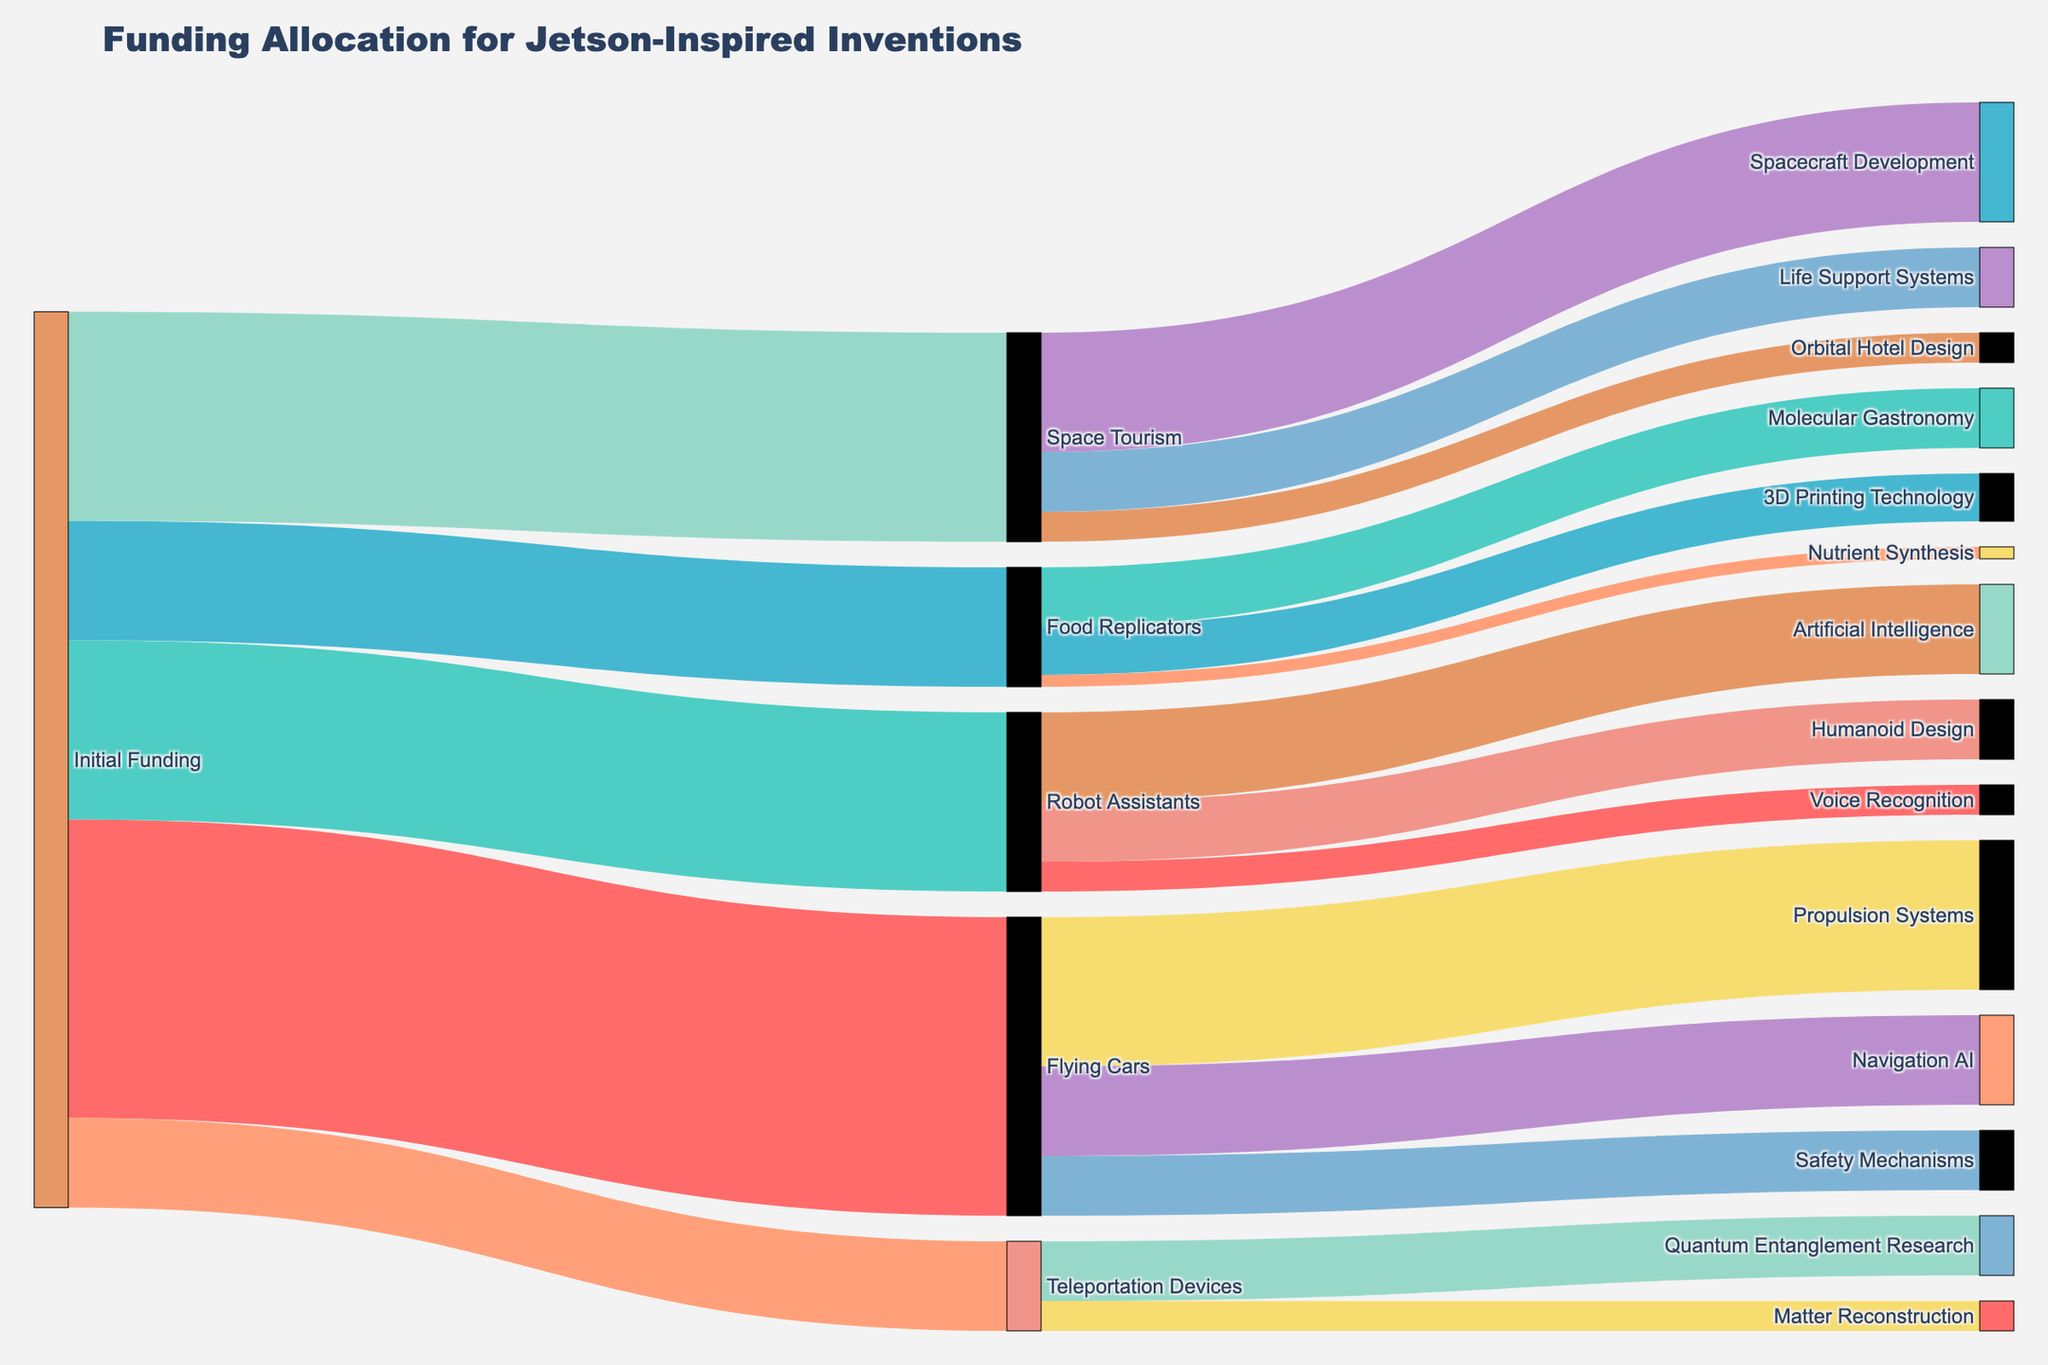What is the primary title of the figure? The title of the figure is displayed at the top, and it reads "Funding Allocation for Jetson-Inspired Inventions".
Answer: Funding Allocation for Jetson-Inspired Inventions How much initial funding was allocated to 'Robot Assistants'? The diagram shows an initial funding allocation line leading to 'Robot Assistants' with a value of 3,000,000.
Answer: 3,000,000 Which sub-category receives the most funding under 'Flying Cars'? There are three sub-categories under 'Flying Cars': Propulsion Systems, Navigation AI, and Safety Mechanisms. Propulsion Systems has the highest value at 2,500,000.
Answer: Propulsion Systems What is the total amount of initial funding allocated to all categories? The figure shows four initial funding allocations: Flying Cars (5,000,000), Robot Assistants (3,000,000), Food Replicators (2,000,000), Teleportation Devices (1,500,000), and Space Tourism (3,500,000). Adding these together: 5,000,000 + 3,000,000 + 2,000,000 + 1,500,000 + 3,500,000 = 15,000,000.
Answer: 15,000,000 Which category receives the least initial funding allocation? Observing the initial funding allocation values, 'Teleportation Devices' receives the least with a value of 1,500,000.
Answer: Teleportation Devices Compare the funding allocated to 'Artificial Intelligence' under 'Robot Assistants' versus 'Navigation AI' under 'Flying Cars'. Which receives more? The values show 'Artificial Intelligence' at 1,500,000 and 'Navigation AI' at 1,500,000. Both receive the same amount of funding.
Answer: Both the same How does the funding for 'Quantum Entanglement Research' compare to '3D Printing Technology'? The figure shows 'Quantum Entanglement Research' under 'Teleportation Devices' with 1,000,000 and '3D Printing Technology' under 'Food Replicators' with 800,000. Quantum Entanglement Research has more funding at 1,000,000.
Answer: Quantum Entanglement Research What is the total funding allocated to sub-categories under 'Space Tourism'? The sub-category values under 'Space Tourism' are: Spacecraft Development (2,000,000), Life Support Systems (1,000,000), and Orbital Hotel Design (500,000). Summing these: 2,000,000 + 1,000,000 + 500,000 = 3,500,000.
Answer: 3,500,000 Which sub-category under 'Food Replicators' has the lowest funding and what is its value? The sub-categories under 'Food Replicators' are Molecular Gastronomy (1,000,000), 3D Printing Technology (800,000), and Nutrient Synthesis (200,000). Nutrient Synthesis has the lowest funding at 200,000.
Answer: Nutrient Synthesis What is the combined funding allocated to 'Flying Cars' and 'Space Tourism'? The initial funding for 'Flying Cars' is 5,000,000 and for 'Space Tourism' is 3,500,000. Adding these together: 5,000,000 + 3,500,000 = 8,500,000.
Answer: 8,500,000 